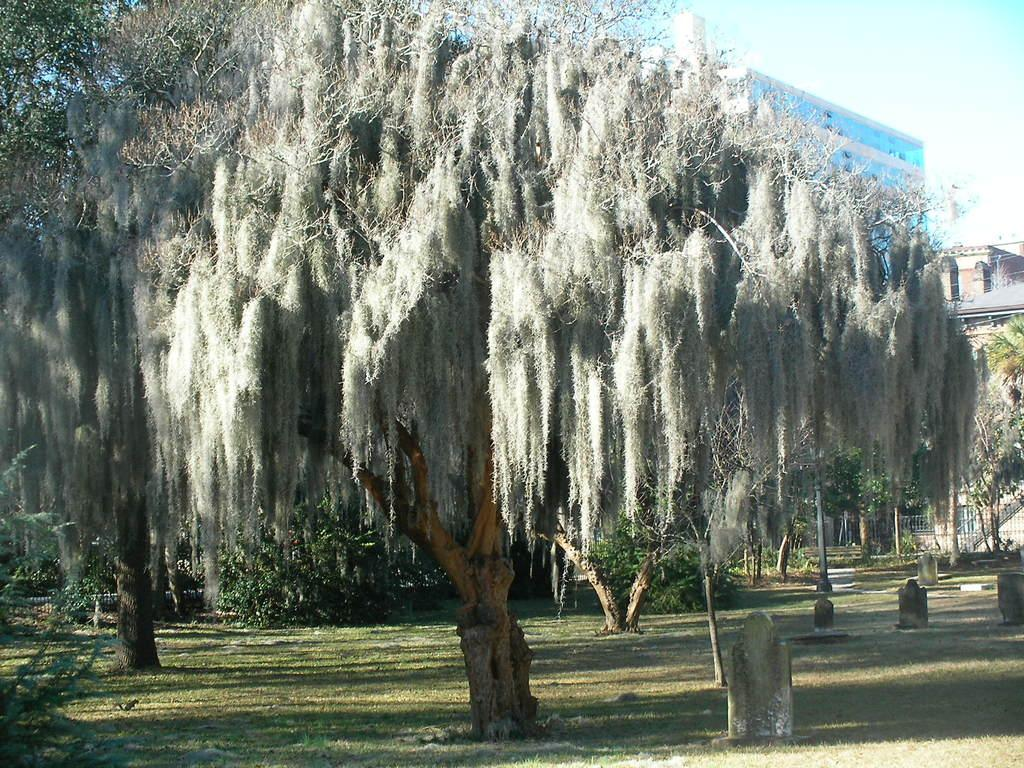What type of vegetation can be seen in the image? There are trees and grass in the image. What type of structures are present in the image? There are headstones and a pole in the image. What can be seen in the background of the image? In the background of the image, there are railings, buildings, and the sky. Where is the basket located in the image? There is no basket present in the image. What type of tool is being used to hammer the headstones in the image? There is no hammer or hammering activity present in the image. 